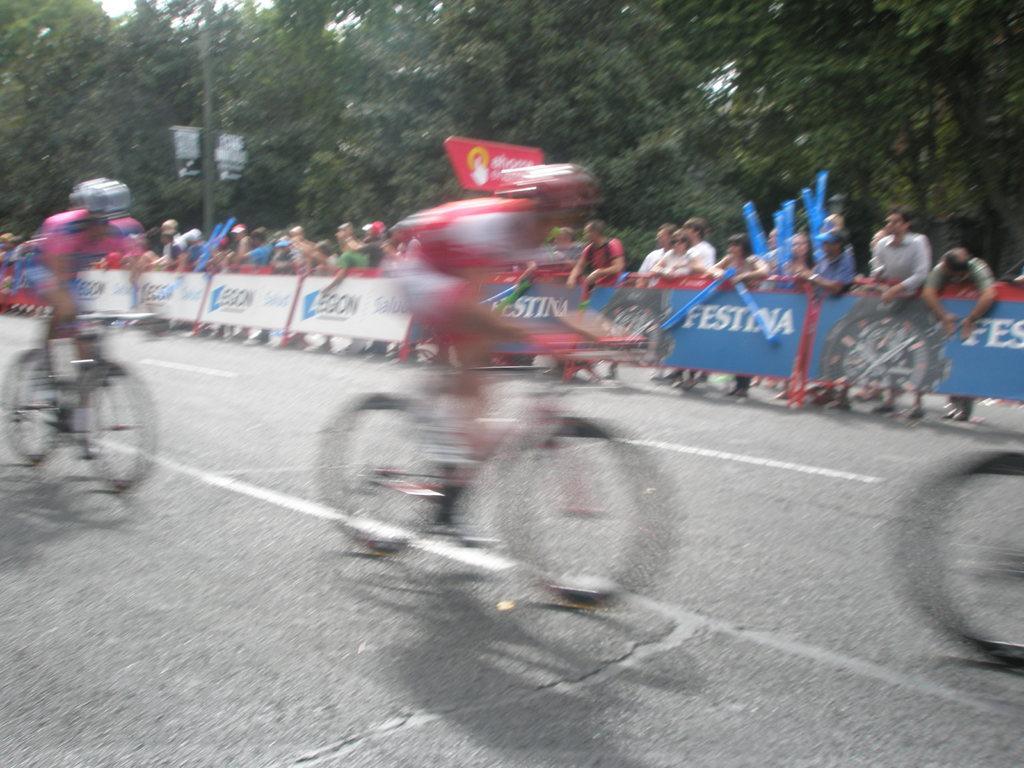Describe this image in one or two sentences. In the image there few people riding bicycle on the road and behind there are many people standing beside a fence, over the background there are trees. 